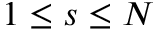Convert formula to latex. <formula><loc_0><loc_0><loc_500><loc_500>1 \leq s \leq N</formula> 